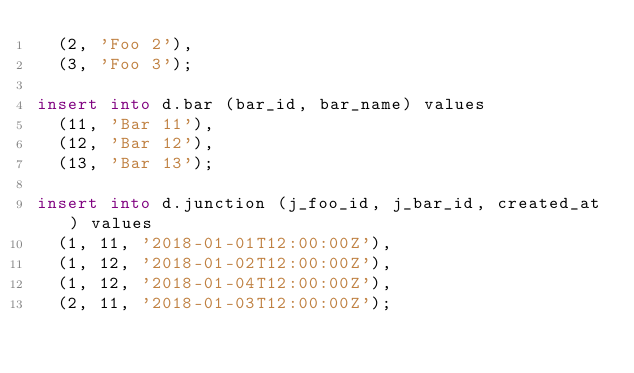<code> <loc_0><loc_0><loc_500><loc_500><_SQL_>  (2, 'Foo 2'),
  (3, 'Foo 3');

insert into d.bar (bar_id, bar_name) values
  (11, 'Bar 11'),
  (12, 'Bar 12'),
  (13, 'Bar 13');

insert into d.junction (j_foo_id, j_bar_id, created_at) values
  (1, 11, '2018-01-01T12:00:00Z'),
  (1, 12, '2018-01-02T12:00:00Z'),
  (1, 12, '2018-01-04T12:00:00Z'),
  (2, 11, '2018-01-03T12:00:00Z');</code> 